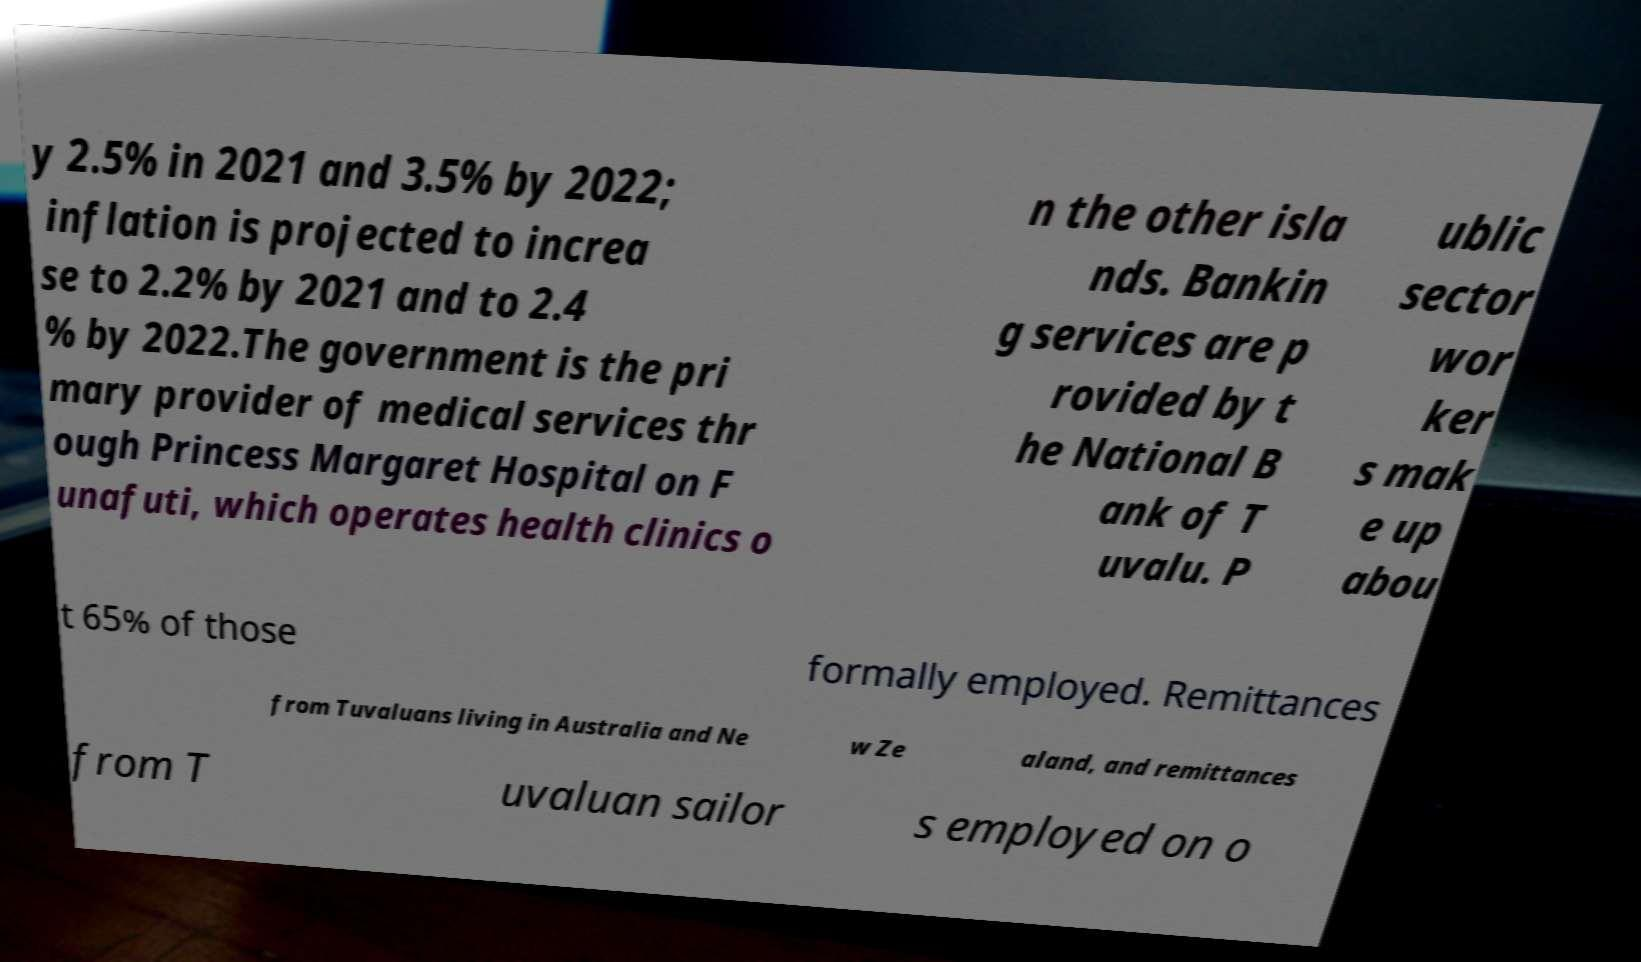For documentation purposes, I need the text within this image transcribed. Could you provide that? y 2.5% in 2021 and 3.5% by 2022; inflation is projected to increa se to 2.2% by 2021 and to 2.4 % by 2022.The government is the pri mary provider of medical services thr ough Princess Margaret Hospital on F unafuti, which operates health clinics o n the other isla nds. Bankin g services are p rovided by t he National B ank of T uvalu. P ublic sector wor ker s mak e up abou t 65% of those formally employed. Remittances from Tuvaluans living in Australia and Ne w Ze aland, and remittances from T uvaluan sailor s employed on o 